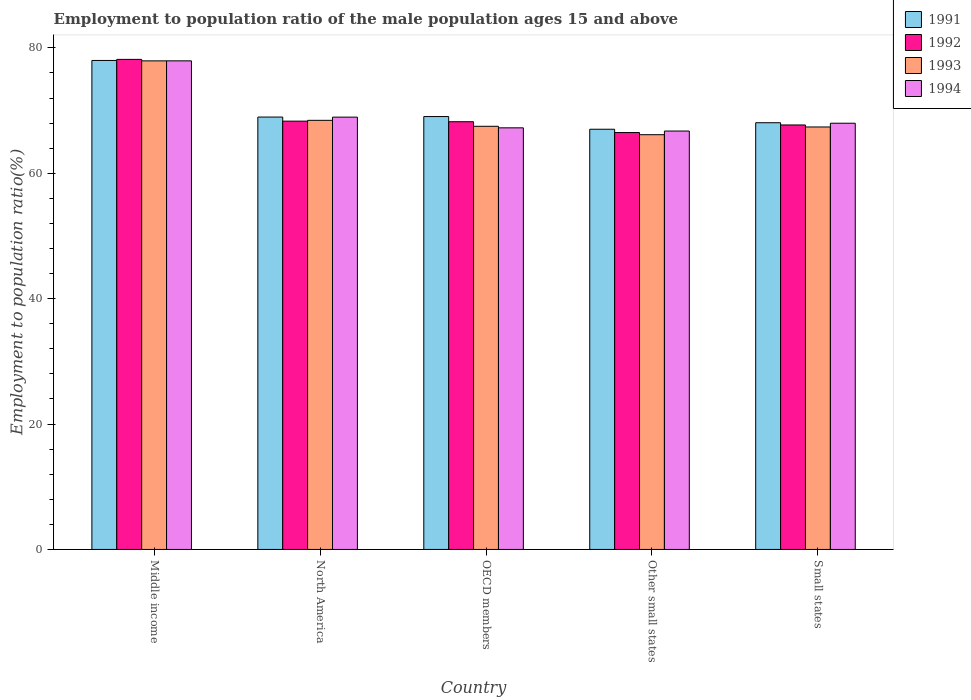How many different coloured bars are there?
Offer a terse response. 4. How many groups of bars are there?
Your answer should be very brief. 5. Are the number of bars per tick equal to the number of legend labels?
Offer a very short reply. Yes. Are the number of bars on each tick of the X-axis equal?
Offer a very short reply. Yes. How many bars are there on the 4th tick from the left?
Give a very brief answer. 4. How many bars are there on the 3rd tick from the right?
Your response must be concise. 4. What is the label of the 2nd group of bars from the left?
Provide a short and direct response. North America. In how many cases, is the number of bars for a given country not equal to the number of legend labels?
Offer a very short reply. 0. What is the employment to population ratio in 1992 in OECD members?
Your answer should be compact. 68.22. Across all countries, what is the maximum employment to population ratio in 1991?
Your answer should be compact. 77.99. Across all countries, what is the minimum employment to population ratio in 1994?
Your answer should be compact. 66.73. In which country was the employment to population ratio in 1994 maximum?
Provide a succinct answer. Middle income. In which country was the employment to population ratio in 1993 minimum?
Offer a very short reply. Other small states. What is the total employment to population ratio in 1991 in the graph?
Keep it short and to the point. 351.08. What is the difference between the employment to population ratio in 1991 in Middle income and that in Small states?
Your answer should be very brief. 9.93. What is the difference between the employment to population ratio in 1992 in North America and the employment to population ratio in 1991 in OECD members?
Offer a terse response. -0.73. What is the average employment to population ratio in 1994 per country?
Keep it short and to the point. 69.77. What is the difference between the employment to population ratio of/in 1993 and employment to population ratio of/in 1991 in Small states?
Your answer should be compact. -0.68. What is the ratio of the employment to population ratio in 1991 in North America to that in OECD members?
Provide a succinct answer. 1. Is the employment to population ratio in 1992 in Other small states less than that in Small states?
Provide a short and direct response. Yes. What is the difference between the highest and the second highest employment to population ratio in 1991?
Keep it short and to the point. -8.95. What is the difference between the highest and the lowest employment to population ratio in 1991?
Offer a terse response. 10.97. Is it the case that in every country, the sum of the employment to population ratio in 1991 and employment to population ratio in 1992 is greater than the sum of employment to population ratio in 1994 and employment to population ratio in 1993?
Your answer should be very brief. No. What does the 1st bar from the left in Small states represents?
Your response must be concise. 1991. Are all the bars in the graph horizontal?
Give a very brief answer. No. How many countries are there in the graph?
Ensure brevity in your answer.  5. Does the graph contain grids?
Your answer should be very brief. No. How many legend labels are there?
Keep it short and to the point. 4. How are the legend labels stacked?
Ensure brevity in your answer.  Vertical. What is the title of the graph?
Make the answer very short. Employment to population ratio of the male population ages 15 and above. What is the Employment to population ratio(%) of 1991 in Middle income?
Make the answer very short. 77.99. What is the Employment to population ratio(%) in 1992 in Middle income?
Make the answer very short. 78.16. What is the Employment to population ratio(%) of 1993 in Middle income?
Offer a terse response. 77.93. What is the Employment to population ratio(%) of 1994 in Middle income?
Your response must be concise. 77.93. What is the Employment to population ratio(%) in 1991 in North America?
Keep it short and to the point. 68.96. What is the Employment to population ratio(%) of 1992 in North America?
Provide a succinct answer. 68.31. What is the Employment to population ratio(%) in 1993 in North America?
Your response must be concise. 68.44. What is the Employment to population ratio(%) in 1994 in North America?
Offer a terse response. 68.95. What is the Employment to population ratio(%) of 1991 in OECD members?
Make the answer very short. 69.04. What is the Employment to population ratio(%) of 1992 in OECD members?
Offer a terse response. 68.22. What is the Employment to population ratio(%) of 1993 in OECD members?
Provide a succinct answer. 67.49. What is the Employment to population ratio(%) of 1994 in OECD members?
Provide a short and direct response. 67.24. What is the Employment to population ratio(%) of 1991 in Other small states?
Provide a succinct answer. 67.02. What is the Employment to population ratio(%) in 1992 in Other small states?
Offer a terse response. 66.49. What is the Employment to population ratio(%) in 1993 in Other small states?
Offer a terse response. 66.15. What is the Employment to population ratio(%) in 1994 in Other small states?
Your response must be concise. 66.73. What is the Employment to population ratio(%) of 1991 in Small states?
Your answer should be very brief. 68.06. What is the Employment to population ratio(%) of 1992 in Small states?
Your answer should be compact. 67.7. What is the Employment to population ratio(%) in 1993 in Small states?
Offer a terse response. 67.38. What is the Employment to population ratio(%) in 1994 in Small states?
Provide a succinct answer. 67.98. Across all countries, what is the maximum Employment to population ratio(%) of 1991?
Provide a succinct answer. 77.99. Across all countries, what is the maximum Employment to population ratio(%) of 1992?
Your answer should be compact. 78.16. Across all countries, what is the maximum Employment to population ratio(%) of 1993?
Provide a short and direct response. 77.93. Across all countries, what is the maximum Employment to population ratio(%) of 1994?
Your response must be concise. 77.93. Across all countries, what is the minimum Employment to population ratio(%) in 1991?
Give a very brief answer. 67.02. Across all countries, what is the minimum Employment to population ratio(%) of 1992?
Provide a short and direct response. 66.49. Across all countries, what is the minimum Employment to population ratio(%) in 1993?
Your response must be concise. 66.15. Across all countries, what is the minimum Employment to population ratio(%) in 1994?
Keep it short and to the point. 66.73. What is the total Employment to population ratio(%) of 1991 in the graph?
Provide a short and direct response. 351.08. What is the total Employment to population ratio(%) of 1992 in the graph?
Your answer should be compact. 348.89. What is the total Employment to population ratio(%) in 1993 in the graph?
Make the answer very short. 347.39. What is the total Employment to population ratio(%) in 1994 in the graph?
Ensure brevity in your answer.  348.84. What is the difference between the Employment to population ratio(%) of 1991 in Middle income and that in North America?
Ensure brevity in your answer.  9.03. What is the difference between the Employment to population ratio(%) of 1992 in Middle income and that in North America?
Your answer should be very brief. 9.85. What is the difference between the Employment to population ratio(%) of 1993 in Middle income and that in North America?
Your answer should be compact. 9.49. What is the difference between the Employment to population ratio(%) of 1994 in Middle income and that in North America?
Offer a very short reply. 8.98. What is the difference between the Employment to population ratio(%) in 1991 in Middle income and that in OECD members?
Your answer should be very brief. 8.95. What is the difference between the Employment to population ratio(%) in 1992 in Middle income and that in OECD members?
Keep it short and to the point. 9.94. What is the difference between the Employment to population ratio(%) of 1993 in Middle income and that in OECD members?
Your response must be concise. 10.43. What is the difference between the Employment to population ratio(%) of 1994 in Middle income and that in OECD members?
Provide a succinct answer. 10.68. What is the difference between the Employment to population ratio(%) in 1991 in Middle income and that in Other small states?
Your answer should be very brief. 10.97. What is the difference between the Employment to population ratio(%) in 1992 in Middle income and that in Other small states?
Ensure brevity in your answer.  11.67. What is the difference between the Employment to population ratio(%) of 1993 in Middle income and that in Other small states?
Your response must be concise. 11.77. What is the difference between the Employment to population ratio(%) of 1994 in Middle income and that in Other small states?
Your answer should be compact. 11.2. What is the difference between the Employment to population ratio(%) of 1991 in Middle income and that in Small states?
Ensure brevity in your answer.  9.93. What is the difference between the Employment to population ratio(%) in 1992 in Middle income and that in Small states?
Provide a short and direct response. 10.46. What is the difference between the Employment to population ratio(%) of 1993 in Middle income and that in Small states?
Ensure brevity in your answer.  10.54. What is the difference between the Employment to population ratio(%) of 1994 in Middle income and that in Small states?
Provide a succinct answer. 9.95. What is the difference between the Employment to population ratio(%) in 1991 in North America and that in OECD members?
Offer a terse response. -0.08. What is the difference between the Employment to population ratio(%) in 1992 in North America and that in OECD members?
Your answer should be compact. 0.09. What is the difference between the Employment to population ratio(%) in 1993 in North America and that in OECD members?
Ensure brevity in your answer.  0.95. What is the difference between the Employment to population ratio(%) of 1994 in North America and that in OECD members?
Offer a very short reply. 1.71. What is the difference between the Employment to population ratio(%) of 1991 in North America and that in Other small states?
Keep it short and to the point. 1.94. What is the difference between the Employment to population ratio(%) of 1992 in North America and that in Other small states?
Provide a short and direct response. 1.82. What is the difference between the Employment to population ratio(%) of 1993 in North America and that in Other small states?
Provide a succinct answer. 2.29. What is the difference between the Employment to population ratio(%) in 1994 in North America and that in Other small states?
Keep it short and to the point. 2.22. What is the difference between the Employment to population ratio(%) in 1991 in North America and that in Small states?
Ensure brevity in your answer.  0.9. What is the difference between the Employment to population ratio(%) of 1992 in North America and that in Small states?
Give a very brief answer. 0.61. What is the difference between the Employment to population ratio(%) in 1993 in North America and that in Small states?
Your answer should be compact. 1.06. What is the difference between the Employment to population ratio(%) in 1994 in North America and that in Small states?
Your answer should be very brief. 0.97. What is the difference between the Employment to population ratio(%) of 1991 in OECD members and that in Other small states?
Provide a succinct answer. 2.03. What is the difference between the Employment to population ratio(%) of 1992 in OECD members and that in Other small states?
Give a very brief answer. 1.73. What is the difference between the Employment to population ratio(%) in 1993 in OECD members and that in Other small states?
Your answer should be very brief. 1.34. What is the difference between the Employment to population ratio(%) in 1994 in OECD members and that in Other small states?
Offer a terse response. 0.51. What is the difference between the Employment to population ratio(%) in 1991 in OECD members and that in Small states?
Give a very brief answer. 0.98. What is the difference between the Employment to population ratio(%) of 1992 in OECD members and that in Small states?
Your response must be concise. 0.52. What is the difference between the Employment to population ratio(%) in 1993 in OECD members and that in Small states?
Provide a succinct answer. 0.11. What is the difference between the Employment to population ratio(%) of 1994 in OECD members and that in Small states?
Keep it short and to the point. -0.73. What is the difference between the Employment to population ratio(%) in 1991 in Other small states and that in Small states?
Provide a succinct answer. -1.04. What is the difference between the Employment to population ratio(%) in 1992 in Other small states and that in Small states?
Ensure brevity in your answer.  -1.21. What is the difference between the Employment to population ratio(%) in 1993 in Other small states and that in Small states?
Provide a succinct answer. -1.23. What is the difference between the Employment to population ratio(%) of 1994 in Other small states and that in Small states?
Offer a very short reply. -1.25. What is the difference between the Employment to population ratio(%) in 1991 in Middle income and the Employment to population ratio(%) in 1992 in North America?
Offer a very short reply. 9.68. What is the difference between the Employment to population ratio(%) in 1991 in Middle income and the Employment to population ratio(%) in 1993 in North America?
Your answer should be compact. 9.55. What is the difference between the Employment to population ratio(%) of 1991 in Middle income and the Employment to population ratio(%) of 1994 in North America?
Your answer should be very brief. 9.04. What is the difference between the Employment to population ratio(%) of 1992 in Middle income and the Employment to population ratio(%) of 1993 in North America?
Make the answer very short. 9.72. What is the difference between the Employment to population ratio(%) of 1992 in Middle income and the Employment to population ratio(%) of 1994 in North America?
Provide a succinct answer. 9.21. What is the difference between the Employment to population ratio(%) of 1993 in Middle income and the Employment to population ratio(%) of 1994 in North America?
Make the answer very short. 8.97. What is the difference between the Employment to population ratio(%) in 1991 in Middle income and the Employment to population ratio(%) in 1992 in OECD members?
Provide a short and direct response. 9.77. What is the difference between the Employment to population ratio(%) of 1991 in Middle income and the Employment to population ratio(%) of 1993 in OECD members?
Provide a short and direct response. 10.5. What is the difference between the Employment to population ratio(%) of 1991 in Middle income and the Employment to population ratio(%) of 1994 in OECD members?
Provide a short and direct response. 10.74. What is the difference between the Employment to population ratio(%) in 1992 in Middle income and the Employment to population ratio(%) in 1993 in OECD members?
Offer a terse response. 10.67. What is the difference between the Employment to population ratio(%) of 1992 in Middle income and the Employment to population ratio(%) of 1994 in OECD members?
Provide a succinct answer. 10.92. What is the difference between the Employment to population ratio(%) of 1993 in Middle income and the Employment to population ratio(%) of 1994 in OECD members?
Provide a short and direct response. 10.68. What is the difference between the Employment to population ratio(%) in 1991 in Middle income and the Employment to population ratio(%) in 1992 in Other small states?
Your answer should be compact. 11.5. What is the difference between the Employment to population ratio(%) of 1991 in Middle income and the Employment to population ratio(%) of 1993 in Other small states?
Give a very brief answer. 11.84. What is the difference between the Employment to population ratio(%) in 1991 in Middle income and the Employment to population ratio(%) in 1994 in Other small states?
Provide a succinct answer. 11.26. What is the difference between the Employment to population ratio(%) of 1992 in Middle income and the Employment to population ratio(%) of 1993 in Other small states?
Give a very brief answer. 12.01. What is the difference between the Employment to population ratio(%) of 1992 in Middle income and the Employment to population ratio(%) of 1994 in Other small states?
Keep it short and to the point. 11.43. What is the difference between the Employment to population ratio(%) of 1993 in Middle income and the Employment to population ratio(%) of 1994 in Other small states?
Your answer should be very brief. 11.19. What is the difference between the Employment to population ratio(%) in 1991 in Middle income and the Employment to population ratio(%) in 1992 in Small states?
Keep it short and to the point. 10.29. What is the difference between the Employment to population ratio(%) of 1991 in Middle income and the Employment to population ratio(%) of 1993 in Small states?
Ensure brevity in your answer.  10.61. What is the difference between the Employment to population ratio(%) in 1991 in Middle income and the Employment to population ratio(%) in 1994 in Small states?
Your answer should be very brief. 10.01. What is the difference between the Employment to population ratio(%) of 1992 in Middle income and the Employment to population ratio(%) of 1993 in Small states?
Make the answer very short. 10.78. What is the difference between the Employment to population ratio(%) in 1992 in Middle income and the Employment to population ratio(%) in 1994 in Small states?
Provide a succinct answer. 10.18. What is the difference between the Employment to population ratio(%) of 1993 in Middle income and the Employment to population ratio(%) of 1994 in Small states?
Provide a succinct answer. 9.95. What is the difference between the Employment to population ratio(%) of 1991 in North America and the Employment to population ratio(%) of 1992 in OECD members?
Offer a terse response. 0.74. What is the difference between the Employment to population ratio(%) of 1991 in North America and the Employment to population ratio(%) of 1993 in OECD members?
Give a very brief answer. 1.47. What is the difference between the Employment to population ratio(%) in 1991 in North America and the Employment to population ratio(%) in 1994 in OECD members?
Provide a short and direct response. 1.72. What is the difference between the Employment to population ratio(%) of 1992 in North America and the Employment to population ratio(%) of 1993 in OECD members?
Your answer should be compact. 0.82. What is the difference between the Employment to population ratio(%) of 1992 in North America and the Employment to population ratio(%) of 1994 in OECD members?
Provide a succinct answer. 1.07. What is the difference between the Employment to population ratio(%) in 1993 in North America and the Employment to population ratio(%) in 1994 in OECD members?
Offer a very short reply. 1.2. What is the difference between the Employment to population ratio(%) of 1991 in North America and the Employment to population ratio(%) of 1992 in Other small states?
Your response must be concise. 2.47. What is the difference between the Employment to population ratio(%) of 1991 in North America and the Employment to population ratio(%) of 1993 in Other small states?
Offer a very short reply. 2.81. What is the difference between the Employment to population ratio(%) of 1991 in North America and the Employment to population ratio(%) of 1994 in Other small states?
Provide a succinct answer. 2.23. What is the difference between the Employment to population ratio(%) in 1992 in North America and the Employment to population ratio(%) in 1993 in Other small states?
Your response must be concise. 2.16. What is the difference between the Employment to population ratio(%) in 1992 in North America and the Employment to population ratio(%) in 1994 in Other small states?
Make the answer very short. 1.58. What is the difference between the Employment to population ratio(%) in 1993 in North America and the Employment to population ratio(%) in 1994 in Other small states?
Offer a terse response. 1.71. What is the difference between the Employment to population ratio(%) in 1991 in North America and the Employment to population ratio(%) in 1992 in Small states?
Offer a terse response. 1.26. What is the difference between the Employment to population ratio(%) in 1991 in North America and the Employment to population ratio(%) in 1993 in Small states?
Provide a succinct answer. 1.58. What is the difference between the Employment to population ratio(%) of 1991 in North America and the Employment to population ratio(%) of 1994 in Small states?
Provide a succinct answer. 0.98. What is the difference between the Employment to population ratio(%) in 1992 in North America and the Employment to population ratio(%) in 1993 in Small states?
Make the answer very short. 0.93. What is the difference between the Employment to population ratio(%) of 1992 in North America and the Employment to population ratio(%) of 1994 in Small states?
Provide a succinct answer. 0.33. What is the difference between the Employment to population ratio(%) of 1993 in North America and the Employment to population ratio(%) of 1994 in Small states?
Ensure brevity in your answer.  0.46. What is the difference between the Employment to population ratio(%) in 1991 in OECD members and the Employment to population ratio(%) in 1992 in Other small states?
Your answer should be very brief. 2.55. What is the difference between the Employment to population ratio(%) in 1991 in OECD members and the Employment to population ratio(%) in 1993 in Other small states?
Your answer should be very brief. 2.89. What is the difference between the Employment to population ratio(%) in 1991 in OECD members and the Employment to population ratio(%) in 1994 in Other small states?
Your response must be concise. 2.31. What is the difference between the Employment to population ratio(%) of 1992 in OECD members and the Employment to population ratio(%) of 1993 in Other small states?
Your answer should be very brief. 2.07. What is the difference between the Employment to population ratio(%) of 1992 in OECD members and the Employment to population ratio(%) of 1994 in Other small states?
Offer a very short reply. 1.49. What is the difference between the Employment to population ratio(%) in 1993 in OECD members and the Employment to population ratio(%) in 1994 in Other small states?
Your answer should be very brief. 0.76. What is the difference between the Employment to population ratio(%) of 1991 in OECD members and the Employment to population ratio(%) of 1992 in Small states?
Your answer should be very brief. 1.34. What is the difference between the Employment to population ratio(%) in 1991 in OECD members and the Employment to population ratio(%) in 1993 in Small states?
Your response must be concise. 1.66. What is the difference between the Employment to population ratio(%) in 1991 in OECD members and the Employment to population ratio(%) in 1994 in Small states?
Give a very brief answer. 1.07. What is the difference between the Employment to population ratio(%) of 1992 in OECD members and the Employment to population ratio(%) of 1993 in Small states?
Make the answer very short. 0.84. What is the difference between the Employment to population ratio(%) of 1992 in OECD members and the Employment to population ratio(%) of 1994 in Small states?
Your answer should be compact. 0.24. What is the difference between the Employment to population ratio(%) in 1993 in OECD members and the Employment to population ratio(%) in 1994 in Small states?
Give a very brief answer. -0.49. What is the difference between the Employment to population ratio(%) in 1991 in Other small states and the Employment to population ratio(%) in 1992 in Small states?
Your answer should be very brief. -0.68. What is the difference between the Employment to population ratio(%) of 1991 in Other small states and the Employment to population ratio(%) of 1993 in Small states?
Provide a short and direct response. -0.36. What is the difference between the Employment to population ratio(%) in 1991 in Other small states and the Employment to population ratio(%) in 1994 in Small states?
Your answer should be very brief. -0.96. What is the difference between the Employment to population ratio(%) of 1992 in Other small states and the Employment to population ratio(%) of 1993 in Small states?
Your response must be concise. -0.89. What is the difference between the Employment to population ratio(%) of 1992 in Other small states and the Employment to population ratio(%) of 1994 in Small states?
Ensure brevity in your answer.  -1.49. What is the difference between the Employment to population ratio(%) of 1993 in Other small states and the Employment to population ratio(%) of 1994 in Small states?
Provide a short and direct response. -1.83. What is the average Employment to population ratio(%) in 1991 per country?
Ensure brevity in your answer.  70.22. What is the average Employment to population ratio(%) in 1992 per country?
Your answer should be very brief. 69.78. What is the average Employment to population ratio(%) in 1993 per country?
Make the answer very short. 69.48. What is the average Employment to population ratio(%) of 1994 per country?
Make the answer very short. 69.77. What is the difference between the Employment to population ratio(%) in 1991 and Employment to population ratio(%) in 1992 in Middle income?
Give a very brief answer. -0.17. What is the difference between the Employment to population ratio(%) of 1991 and Employment to population ratio(%) of 1993 in Middle income?
Offer a terse response. 0.06. What is the difference between the Employment to population ratio(%) in 1991 and Employment to population ratio(%) in 1994 in Middle income?
Your answer should be very brief. 0.06. What is the difference between the Employment to population ratio(%) in 1992 and Employment to population ratio(%) in 1993 in Middle income?
Your answer should be very brief. 0.24. What is the difference between the Employment to population ratio(%) in 1992 and Employment to population ratio(%) in 1994 in Middle income?
Offer a terse response. 0.23. What is the difference between the Employment to population ratio(%) in 1993 and Employment to population ratio(%) in 1994 in Middle income?
Your answer should be compact. -0. What is the difference between the Employment to population ratio(%) of 1991 and Employment to population ratio(%) of 1992 in North America?
Your response must be concise. 0.65. What is the difference between the Employment to population ratio(%) in 1991 and Employment to population ratio(%) in 1993 in North America?
Ensure brevity in your answer.  0.52. What is the difference between the Employment to population ratio(%) in 1991 and Employment to population ratio(%) in 1994 in North America?
Your response must be concise. 0.01. What is the difference between the Employment to population ratio(%) of 1992 and Employment to population ratio(%) of 1993 in North America?
Ensure brevity in your answer.  -0.13. What is the difference between the Employment to population ratio(%) of 1992 and Employment to population ratio(%) of 1994 in North America?
Your answer should be compact. -0.64. What is the difference between the Employment to population ratio(%) in 1993 and Employment to population ratio(%) in 1994 in North America?
Provide a short and direct response. -0.51. What is the difference between the Employment to population ratio(%) of 1991 and Employment to population ratio(%) of 1992 in OECD members?
Give a very brief answer. 0.83. What is the difference between the Employment to population ratio(%) of 1991 and Employment to population ratio(%) of 1993 in OECD members?
Your response must be concise. 1.55. What is the difference between the Employment to population ratio(%) in 1991 and Employment to population ratio(%) in 1994 in OECD members?
Offer a terse response. 1.8. What is the difference between the Employment to population ratio(%) in 1992 and Employment to population ratio(%) in 1993 in OECD members?
Your answer should be very brief. 0.73. What is the difference between the Employment to population ratio(%) of 1992 and Employment to population ratio(%) of 1994 in OECD members?
Keep it short and to the point. 0.97. What is the difference between the Employment to population ratio(%) of 1993 and Employment to population ratio(%) of 1994 in OECD members?
Offer a very short reply. 0.25. What is the difference between the Employment to population ratio(%) of 1991 and Employment to population ratio(%) of 1992 in Other small states?
Your answer should be compact. 0.53. What is the difference between the Employment to population ratio(%) of 1991 and Employment to population ratio(%) of 1993 in Other small states?
Give a very brief answer. 0.87. What is the difference between the Employment to population ratio(%) of 1991 and Employment to population ratio(%) of 1994 in Other small states?
Keep it short and to the point. 0.29. What is the difference between the Employment to population ratio(%) of 1992 and Employment to population ratio(%) of 1993 in Other small states?
Offer a very short reply. 0.34. What is the difference between the Employment to population ratio(%) in 1992 and Employment to population ratio(%) in 1994 in Other small states?
Your answer should be compact. -0.24. What is the difference between the Employment to population ratio(%) in 1993 and Employment to population ratio(%) in 1994 in Other small states?
Provide a short and direct response. -0.58. What is the difference between the Employment to population ratio(%) in 1991 and Employment to population ratio(%) in 1992 in Small states?
Offer a very short reply. 0.36. What is the difference between the Employment to population ratio(%) in 1991 and Employment to population ratio(%) in 1993 in Small states?
Ensure brevity in your answer.  0.68. What is the difference between the Employment to population ratio(%) of 1991 and Employment to population ratio(%) of 1994 in Small states?
Offer a terse response. 0.08. What is the difference between the Employment to population ratio(%) of 1992 and Employment to population ratio(%) of 1993 in Small states?
Keep it short and to the point. 0.32. What is the difference between the Employment to population ratio(%) of 1992 and Employment to population ratio(%) of 1994 in Small states?
Provide a succinct answer. -0.28. What is the difference between the Employment to population ratio(%) of 1993 and Employment to population ratio(%) of 1994 in Small states?
Ensure brevity in your answer.  -0.6. What is the ratio of the Employment to population ratio(%) of 1991 in Middle income to that in North America?
Your answer should be compact. 1.13. What is the ratio of the Employment to population ratio(%) of 1992 in Middle income to that in North America?
Your answer should be compact. 1.14. What is the ratio of the Employment to population ratio(%) of 1993 in Middle income to that in North America?
Offer a very short reply. 1.14. What is the ratio of the Employment to population ratio(%) in 1994 in Middle income to that in North America?
Your response must be concise. 1.13. What is the ratio of the Employment to population ratio(%) in 1991 in Middle income to that in OECD members?
Keep it short and to the point. 1.13. What is the ratio of the Employment to population ratio(%) of 1992 in Middle income to that in OECD members?
Make the answer very short. 1.15. What is the ratio of the Employment to population ratio(%) in 1993 in Middle income to that in OECD members?
Offer a terse response. 1.15. What is the ratio of the Employment to population ratio(%) in 1994 in Middle income to that in OECD members?
Offer a very short reply. 1.16. What is the ratio of the Employment to population ratio(%) of 1991 in Middle income to that in Other small states?
Offer a very short reply. 1.16. What is the ratio of the Employment to population ratio(%) in 1992 in Middle income to that in Other small states?
Your response must be concise. 1.18. What is the ratio of the Employment to population ratio(%) in 1993 in Middle income to that in Other small states?
Your answer should be compact. 1.18. What is the ratio of the Employment to population ratio(%) of 1994 in Middle income to that in Other small states?
Offer a very short reply. 1.17. What is the ratio of the Employment to population ratio(%) of 1991 in Middle income to that in Small states?
Give a very brief answer. 1.15. What is the ratio of the Employment to population ratio(%) of 1992 in Middle income to that in Small states?
Ensure brevity in your answer.  1.15. What is the ratio of the Employment to population ratio(%) of 1993 in Middle income to that in Small states?
Give a very brief answer. 1.16. What is the ratio of the Employment to population ratio(%) in 1994 in Middle income to that in Small states?
Your answer should be compact. 1.15. What is the ratio of the Employment to population ratio(%) of 1991 in North America to that in OECD members?
Your response must be concise. 1. What is the ratio of the Employment to population ratio(%) in 1994 in North America to that in OECD members?
Ensure brevity in your answer.  1.03. What is the ratio of the Employment to population ratio(%) of 1991 in North America to that in Other small states?
Make the answer very short. 1.03. What is the ratio of the Employment to population ratio(%) of 1992 in North America to that in Other small states?
Provide a succinct answer. 1.03. What is the ratio of the Employment to population ratio(%) in 1993 in North America to that in Other small states?
Provide a short and direct response. 1.03. What is the ratio of the Employment to population ratio(%) in 1994 in North America to that in Other small states?
Offer a very short reply. 1.03. What is the ratio of the Employment to population ratio(%) of 1991 in North America to that in Small states?
Make the answer very short. 1.01. What is the ratio of the Employment to population ratio(%) in 1993 in North America to that in Small states?
Offer a terse response. 1.02. What is the ratio of the Employment to population ratio(%) in 1994 in North America to that in Small states?
Your response must be concise. 1.01. What is the ratio of the Employment to population ratio(%) of 1991 in OECD members to that in Other small states?
Keep it short and to the point. 1.03. What is the ratio of the Employment to population ratio(%) of 1992 in OECD members to that in Other small states?
Provide a short and direct response. 1.03. What is the ratio of the Employment to population ratio(%) of 1993 in OECD members to that in Other small states?
Ensure brevity in your answer.  1.02. What is the ratio of the Employment to population ratio(%) in 1994 in OECD members to that in Other small states?
Ensure brevity in your answer.  1.01. What is the ratio of the Employment to population ratio(%) in 1991 in OECD members to that in Small states?
Provide a succinct answer. 1.01. What is the ratio of the Employment to population ratio(%) in 1992 in OECD members to that in Small states?
Make the answer very short. 1.01. What is the ratio of the Employment to population ratio(%) in 1991 in Other small states to that in Small states?
Keep it short and to the point. 0.98. What is the ratio of the Employment to population ratio(%) of 1992 in Other small states to that in Small states?
Provide a short and direct response. 0.98. What is the ratio of the Employment to population ratio(%) in 1993 in Other small states to that in Small states?
Make the answer very short. 0.98. What is the ratio of the Employment to population ratio(%) of 1994 in Other small states to that in Small states?
Give a very brief answer. 0.98. What is the difference between the highest and the second highest Employment to population ratio(%) of 1991?
Offer a terse response. 8.95. What is the difference between the highest and the second highest Employment to population ratio(%) of 1992?
Provide a short and direct response. 9.85. What is the difference between the highest and the second highest Employment to population ratio(%) in 1993?
Keep it short and to the point. 9.49. What is the difference between the highest and the second highest Employment to population ratio(%) in 1994?
Make the answer very short. 8.98. What is the difference between the highest and the lowest Employment to population ratio(%) of 1991?
Provide a short and direct response. 10.97. What is the difference between the highest and the lowest Employment to population ratio(%) of 1992?
Your response must be concise. 11.67. What is the difference between the highest and the lowest Employment to population ratio(%) in 1993?
Your answer should be compact. 11.77. What is the difference between the highest and the lowest Employment to population ratio(%) of 1994?
Keep it short and to the point. 11.2. 